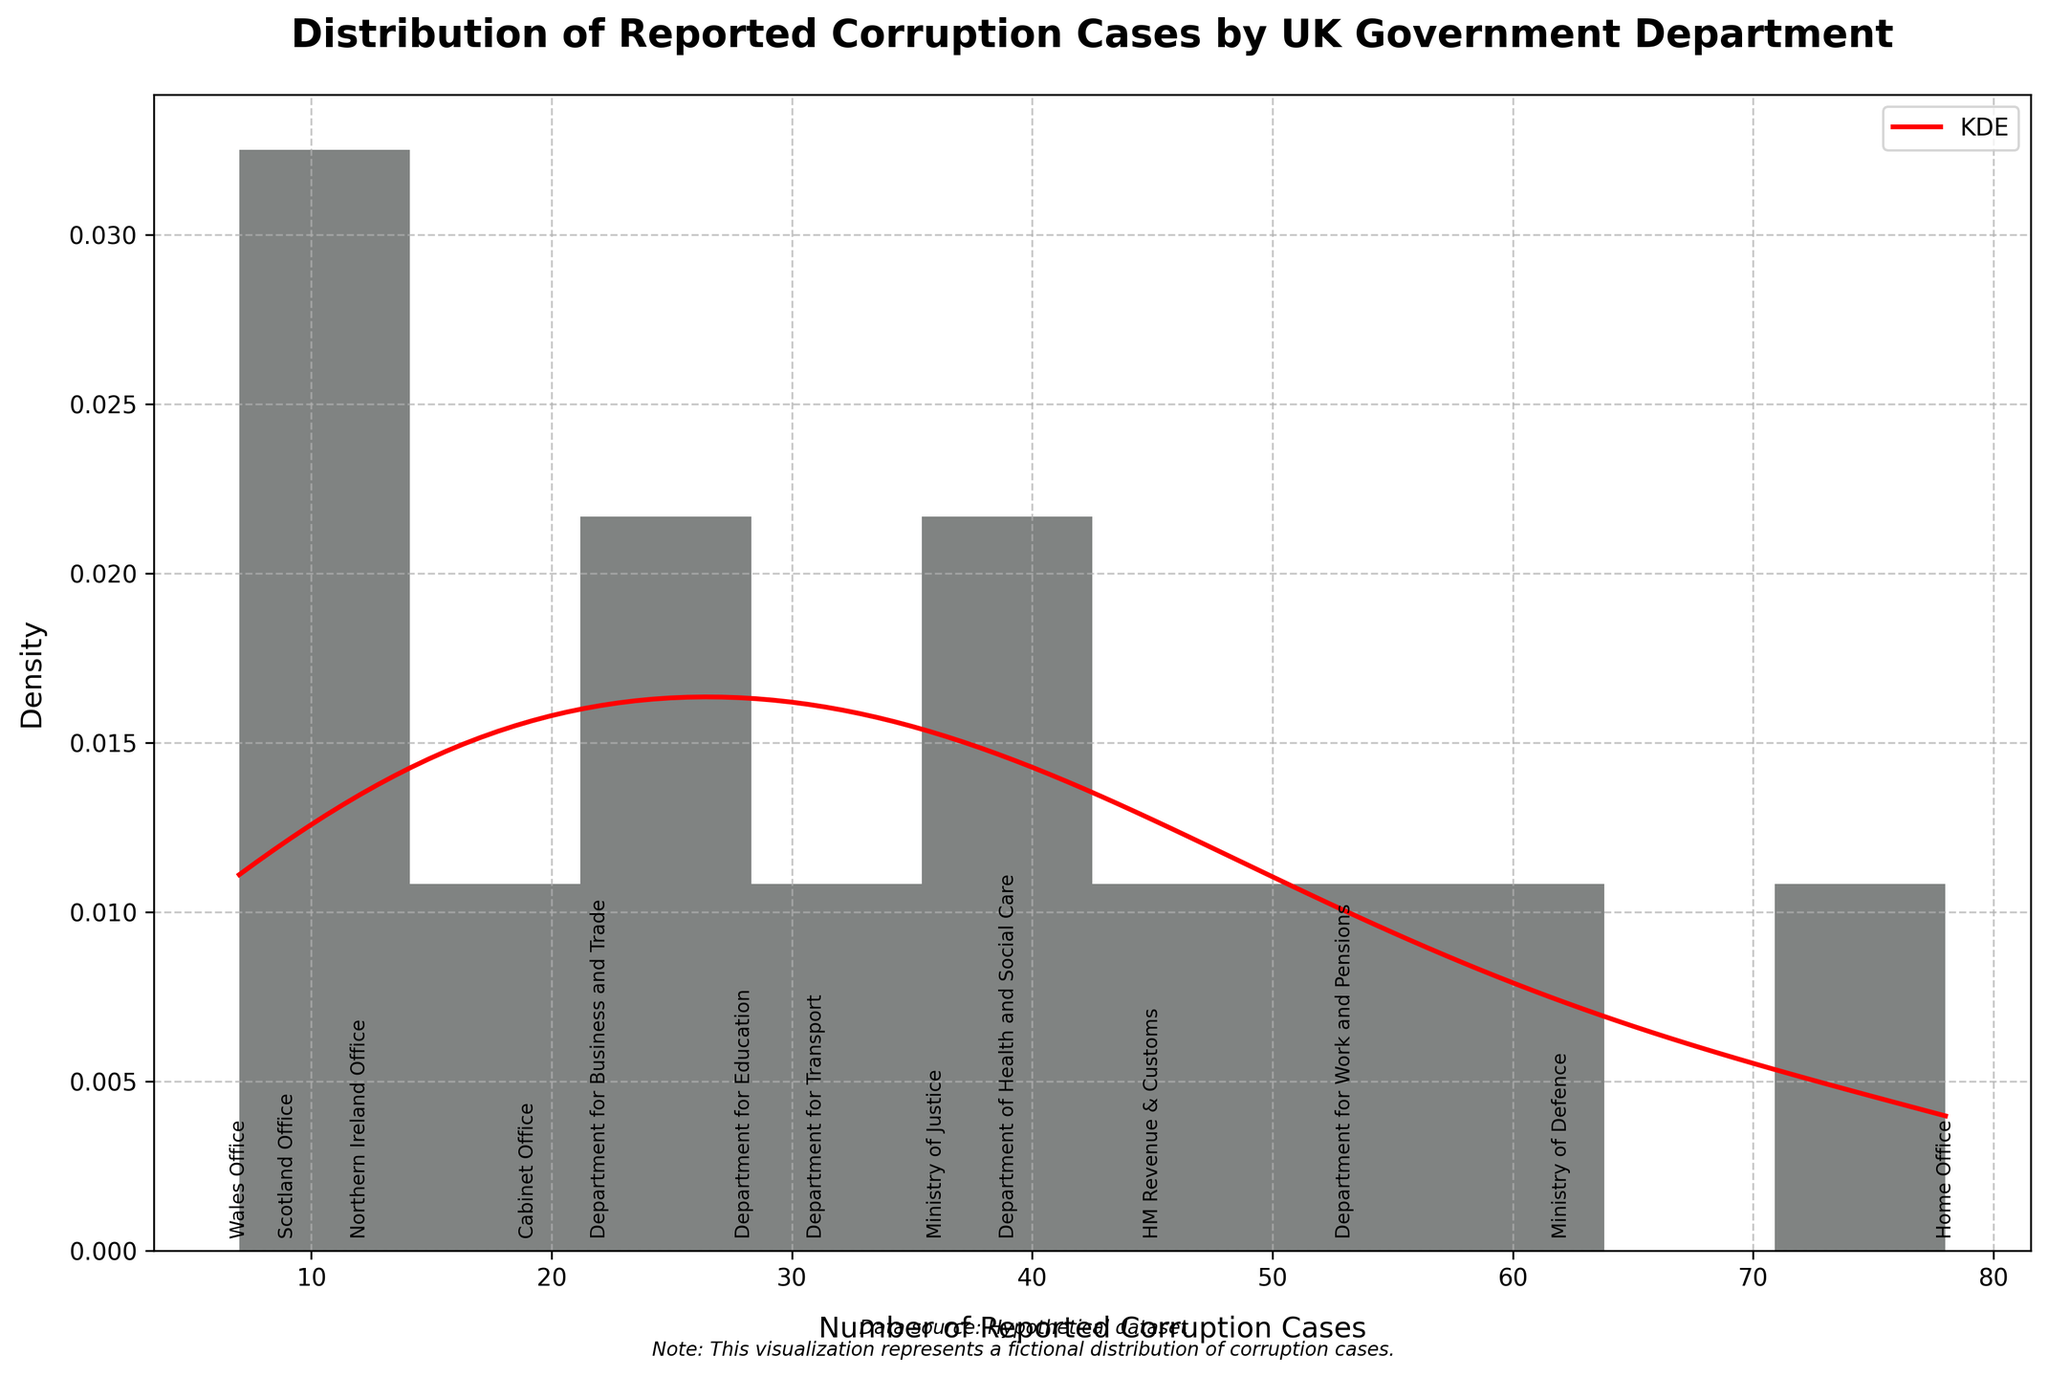What is the title of the figure? The title is typically located at the top of the figure, often in a larger or bolder font. Simply read the title to identify it.
Answer: Distribution of Reported Corruption Cases by UK Government Department What is the range of the x-axis representing the number of reported corruption cases? The x-axis range can be identified by observing the scale or the minimum and maximum values labeled on the axis.
Answer: 0 to 80 Which department had the highest number of reported corruption cases, and what is that number? Look for the highest data point on the histogram and refer to the annotation to identify the department and the reported number of cases.
Answer: Home Office, 78 What can you infer from the density curve in relation to the concentration of reported corruption cases? The density curve peaks indicate where the data points are most concentrated. A higher peak shows greater density, indicating more frequent occurrences within that range.
Answer: Most reported corruption cases are concentrated around 25-45 cases Which department reported fewer corruption cases, the Department for Education or the Department of Health and Social Care, and by how many? Locate both departments on the histogram and check their corresponding values. Subtract the smaller value from the larger value for the difference.
Answer: Department for Education, by 11 cases (28 compared to 39) Can you identify any department(s) with fewer than 10 reported corruption cases? Observe the annotations and the histogram bars that represent values less than 10 reported corruption cases.
Answer: Scotland Office and Wales Office How does the number of reported corruption cases from the Ministry of Justice compare to the Department for Transport? Look at the values for both departments as annotated on the histogram and compare them directly.
Answer: Ministry of Justice has more cases (36 vs. 31) What is the general trend shown by the histogram and KDE in terms of frequency and distribution? Observe the shape and distribution of the histogram bars and the KDE curve to infer overall trends in data frequency.
Answer: The trend shows fewer departments reporting very high numbers of corruption cases, with most falling between 25-45 reported cases How many departments have reported between 20 and 40 corruption cases? Count the number of histogram bars (or departments) that fall between the values of 20 and 40 on the x-axis, using annotations as guides.
Answer: Four departments What might the spread of data from the histogram suggest about corruption reporting across departments? Consider the range, density, and spread of the data represented in the histogram to infer possible variations in reporting.
Answer: It suggests variability in reporting, with a few departments having significantly higher cases and many with moderate to low counts 